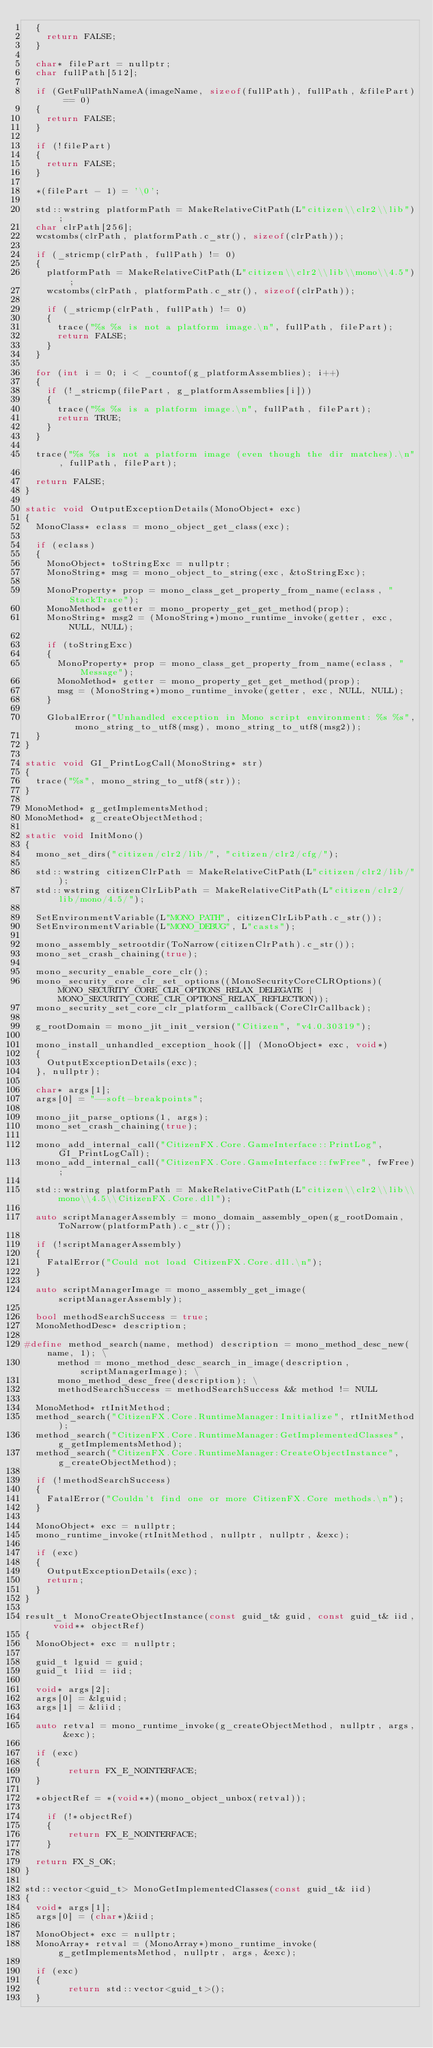Convert code to text. <code><loc_0><loc_0><loc_500><loc_500><_C++_>	{
		return FALSE;
	}

	char* filePart = nullptr;
	char fullPath[512];

	if (GetFullPathNameA(imageName, sizeof(fullPath), fullPath, &filePart) == 0)
	{
		return FALSE;
	}

	if (!filePart)
	{
		return FALSE;
	}

	*(filePart - 1) = '\0';

	std::wstring platformPath = MakeRelativeCitPath(L"citizen\\clr2\\lib");
	char clrPath[256];
	wcstombs(clrPath, platformPath.c_str(), sizeof(clrPath));

	if (_stricmp(clrPath, fullPath) != 0)
	{
		platformPath = MakeRelativeCitPath(L"citizen\\clr2\\lib\\mono\\4.5");
		wcstombs(clrPath, platformPath.c_str(), sizeof(clrPath));

		if (_stricmp(clrPath, fullPath) != 0)
		{
			trace("%s %s is not a platform image.\n", fullPath, filePart);
			return FALSE;
		}
	}

	for (int i = 0; i < _countof(g_platformAssemblies); i++)
	{
		if (!_stricmp(filePart, g_platformAssemblies[i]))
		{
			trace("%s %s is a platform image.\n", fullPath, filePart);
			return TRUE;
		}
	}

	trace("%s %s is not a platform image (even though the dir matches).\n", fullPath, filePart);

	return FALSE;
}

static void OutputExceptionDetails(MonoObject* exc)
{
	MonoClass* eclass = mono_object_get_class(exc);

	if (eclass)
	{
		MonoObject* toStringExc = nullptr;
		MonoString* msg = mono_object_to_string(exc, &toStringExc);

		MonoProperty* prop = mono_class_get_property_from_name(eclass, "StackTrace");
		MonoMethod* getter = mono_property_get_get_method(prop);
		MonoString* msg2 = (MonoString*)mono_runtime_invoke(getter, exc, NULL, NULL);

		if (toStringExc)
		{
			MonoProperty* prop = mono_class_get_property_from_name(eclass, "Message");
			MonoMethod* getter = mono_property_get_get_method(prop);
			msg = (MonoString*)mono_runtime_invoke(getter, exc, NULL, NULL);
		}

		GlobalError("Unhandled exception in Mono script environment: %s %s", mono_string_to_utf8(msg), mono_string_to_utf8(msg2));
	}
}

static void GI_PrintLogCall(MonoString* str)
{
	trace("%s", mono_string_to_utf8(str));
}

MonoMethod* g_getImplementsMethod;
MonoMethod* g_createObjectMethod;

static void InitMono()
{
	mono_set_dirs("citizen/clr2/lib/", "citizen/clr2/cfg/");

	std::wstring citizenClrPath = MakeRelativeCitPath(L"citizen/clr2/lib/");
	std::wstring citizenClrLibPath = MakeRelativeCitPath(L"citizen/clr2/lib/mono/4.5/");

	SetEnvironmentVariable(L"MONO_PATH", citizenClrLibPath.c_str());
	SetEnvironmentVariable(L"MONO_DEBUG", L"casts");

	mono_assembly_setrootdir(ToNarrow(citizenClrPath).c_str());
	mono_set_crash_chaining(true);

	mono_security_enable_core_clr();
	mono_security_core_clr_set_options((MonoSecurityCoreCLROptions)(MONO_SECURITY_CORE_CLR_OPTIONS_RELAX_DELEGATE | MONO_SECURITY_CORE_CLR_OPTIONS_RELAX_REFLECTION));
	mono_security_set_core_clr_platform_callback(CoreClrCallback);

	g_rootDomain = mono_jit_init_version("Citizen", "v4.0.30319");

	mono_install_unhandled_exception_hook([] (MonoObject* exc, void*)
	{
		OutputExceptionDetails(exc);
	}, nullptr);

	char* args[1];
	args[0] = "--soft-breakpoints";

	mono_jit_parse_options(1, args);
	mono_set_crash_chaining(true);

	mono_add_internal_call("CitizenFX.Core.GameInterface::PrintLog", GI_PrintLogCall);
	mono_add_internal_call("CitizenFX.Core.GameInterface::fwFree", fwFree);

	std::wstring platformPath = MakeRelativeCitPath(L"citizen\\clr2\\lib\\mono\\4.5\\CitizenFX.Core.dll");

	auto scriptManagerAssembly = mono_domain_assembly_open(g_rootDomain, ToNarrow(platformPath).c_str());

	if (!scriptManagerAssembly)
	{
		FatalError("Could not load CitizenFX.Core.dll.\n");
	}

	auto scriptManagerImage = mono_assembly_get_image(scriptManagerAssembly);

	bool methodSearchSuccess = true;
	MonoMethodDesc* description;

#define method_search(name, method) description = mono_method_desc_new(name, 1); \
			method = mono_method_desc_search_in_image(description, scriptManagerImage); \
			mono_method_desc_free(description); \
			methodSearchSuccess = methodSearchSuccess && method != NULL

	MonoMethod* rtInitMethod;
	method_search("CitizenFX.Core.RuntimeManager:Initialize", rtInitMethod);
	method_search("CitizenFX.Core.RuntimeManager:GetImplementedClasses", g_getImplementsMethod);
	method_search("CitizenFX.Core.RuntimeManager:CreateObjectInstance", g_createObjectMethod);

	if (!methodSearchSuccess)
	{
		FatalError("Couldn't find one or more CitizenFX.Core methods.\n");
	}

	MonoObject* exc = nullptr;
	mono_runtime_invoke(rtInitMethod, nullptr, nullptr, &exc);

	if (exc)
	{
		OutputExceptionDetails(exc);
		return;
	}
}

result_t MonoCreateObjectInstance(const guid_t& guid, const guid_t& iid, void** objectRef)
{
	MonoObject* exc = nullptr;

	guid_t lguid = guid;
	guid_t liid = iid;

	void* args[2];
	args[0] = &lguid;
	args[1] = &liid;

	auto retval = mono_runtime_invoke(g_createObjectMethod, nullptr, args, &exc);

	if (exc)
	{
        return FX_E_NOINTERFACE;
	}

	*objectRef = *(void**)(mono_object_unbox(retval));

    if (!*objectRef)
    {
        return FX_E_NOINTERFACE;
    }

	return FX_S_OK;
}

std::vector<guid_t> MonoGetImplementedClasses(const guid_t& iid)
{
	void* args[1];
	args[0] = (char*)&iid;

	MonoObject* exc = nullptr;
	MonoArray* retval = (MonoArray*)mono_runtime_invoke(g_getImplementsMethod, nullptr, args, &exc);

	if (exc)
	{
        return std::vector<guid_t>();
	}
</code> 